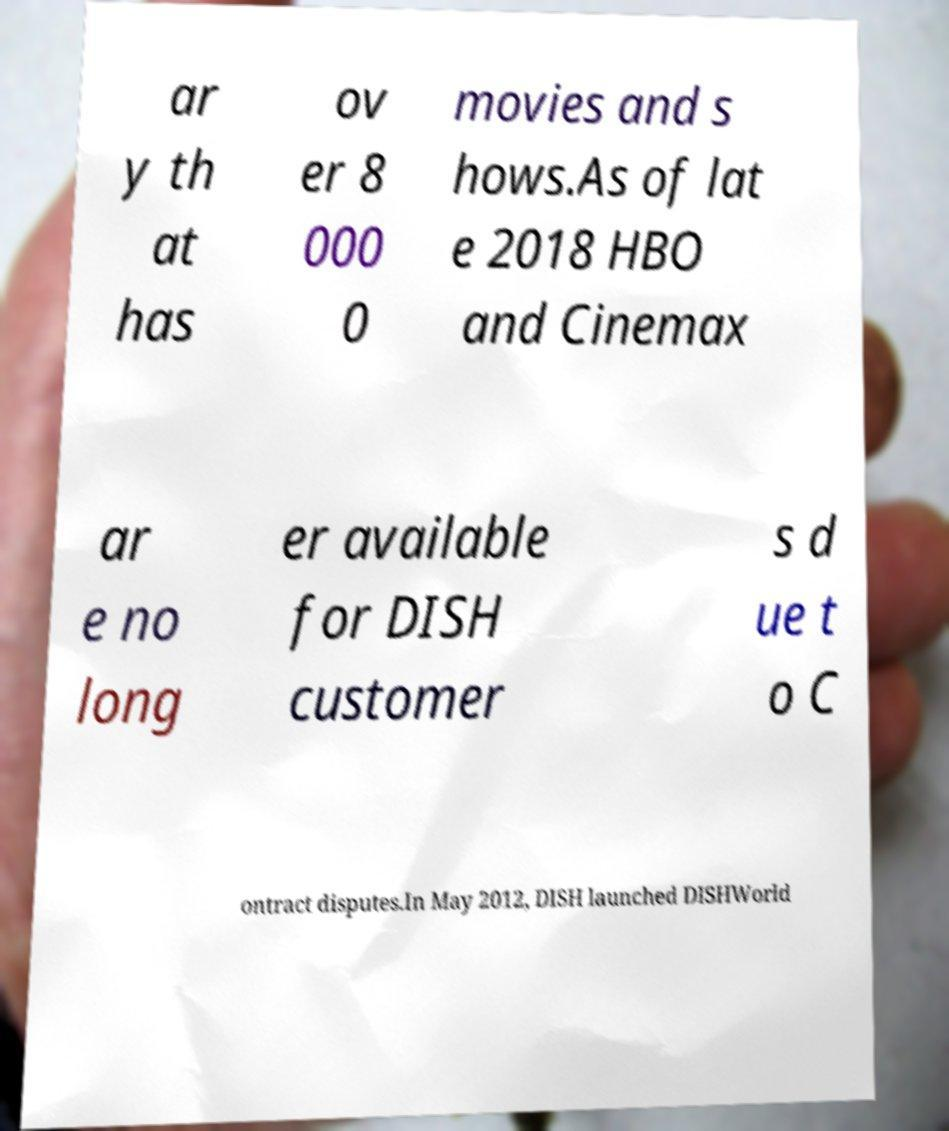For documentation purposes, I need the text within this image transcribed. Could you provide that? ar y th at has ov er 8 000 0 movies and s hows.As of lat e 2018 HBO and Cinemax ar e no long er available for DISH customer s d ue t o C ontract disputes.In May 2012, DISH launched DISHWorld 